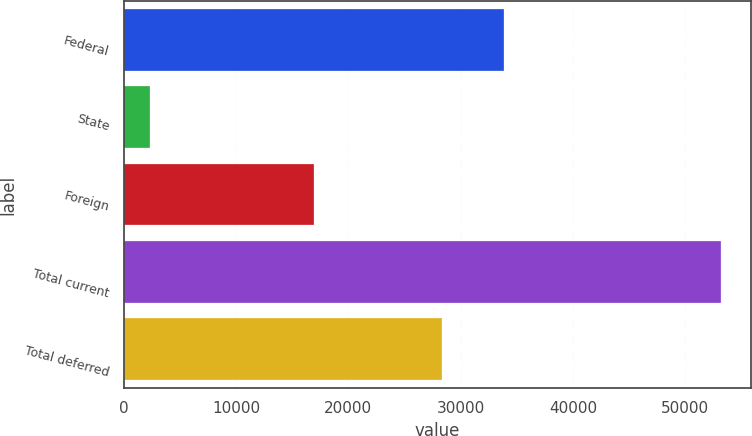Convert chart. <chart><loc_0><loc_0><loc_500><loc_500><bar_chart><fcel>Federal<fcel>State<fcel>Foreign<fcel>Total current<fcel>Total deferred<nl><fcel>33856<fcel>2350<fcel>16950<fcel>53156<fcel>28368<nl></chart> 